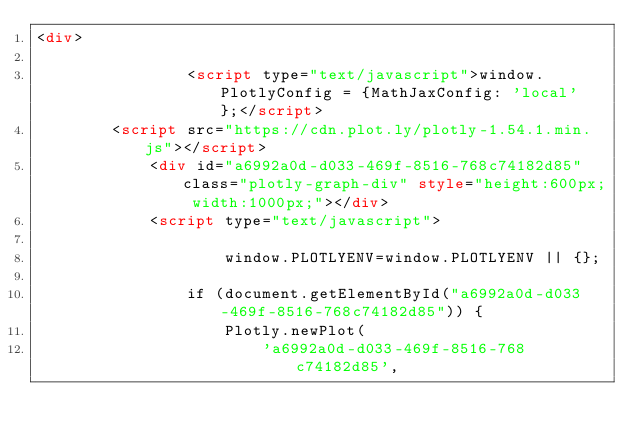<code> <loc_0><loc_0><loc_500><loc_500><_HTML_><div>
        
                <script type="text/javascript">window.PlotlyConfig = {MathJaxConfig: 'local'};</script>
        <script src="https://cdn.plot.ly/plotly-1.54.1.min.js"></script>    
            <div id="a6992a0d-d033-469f-8516-768c74182d85" class="plotly-graph-div" style="height:600px; width:1000px;"></div>
            <script type="text/javascript">
                
                    window.PLOTLYENV=window.PLOTLYENV || {};
                    
                if (document.getElementById("a6992a0d-d033-469f-8516-768c74182d85")) {
                    Plotly.newPlot(
                        'a6992a0d-d033-469f-8516-768c74182d85',</code> 